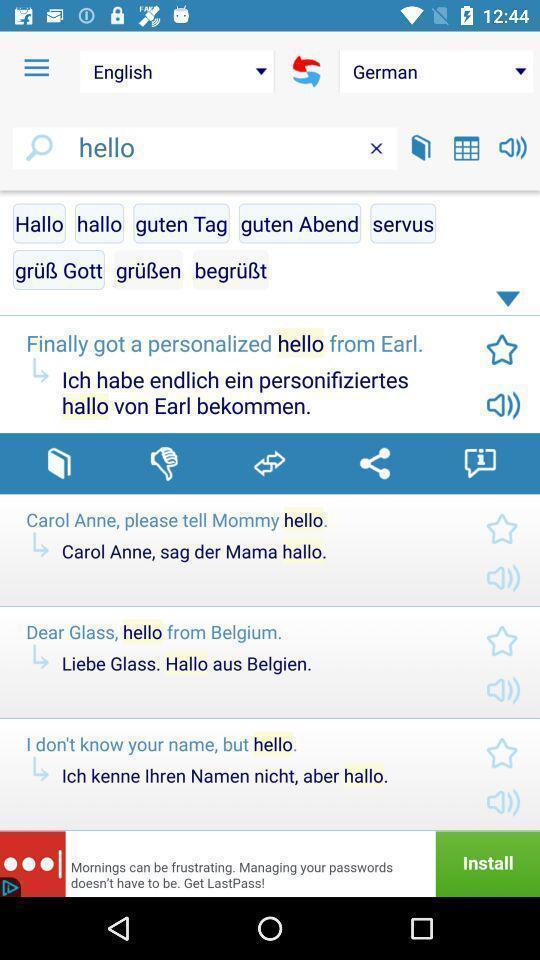Provide a detailed account of this screenshot. Screen page displaying various options in language translation application. 